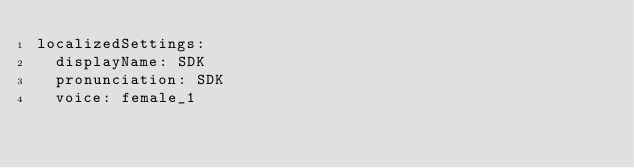<code> <loc_0><loc_0><loc_500><loc_500><_YAML_>localizedSettings:
  displayName: SDK
  pronunciation: SDK
  voice: female_1
</code> 